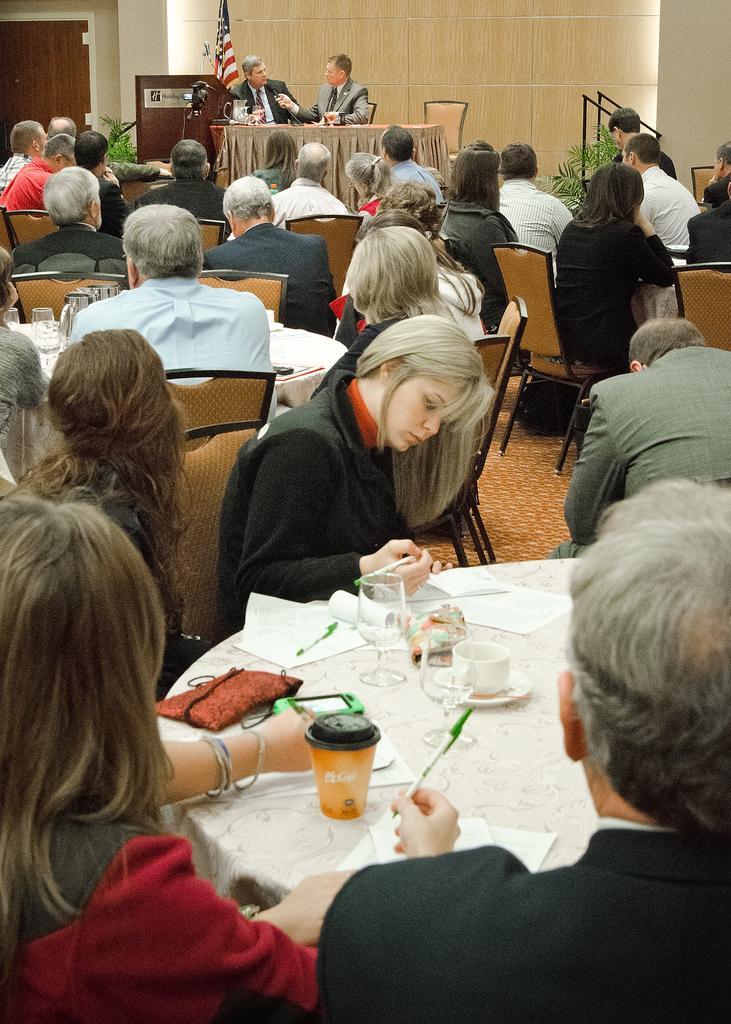Could you give a brief overview of what you see in this image? in this picture we can see all the persons sitting on chairs in front of a table and on the table we can see cups, saucers, glasses, purse, pen and paper. This is a floor. We can see two men sitting on chairs in front of a table and on the table we can see a jar. Behind to them there is a flag. This is a plant. This is a door. 